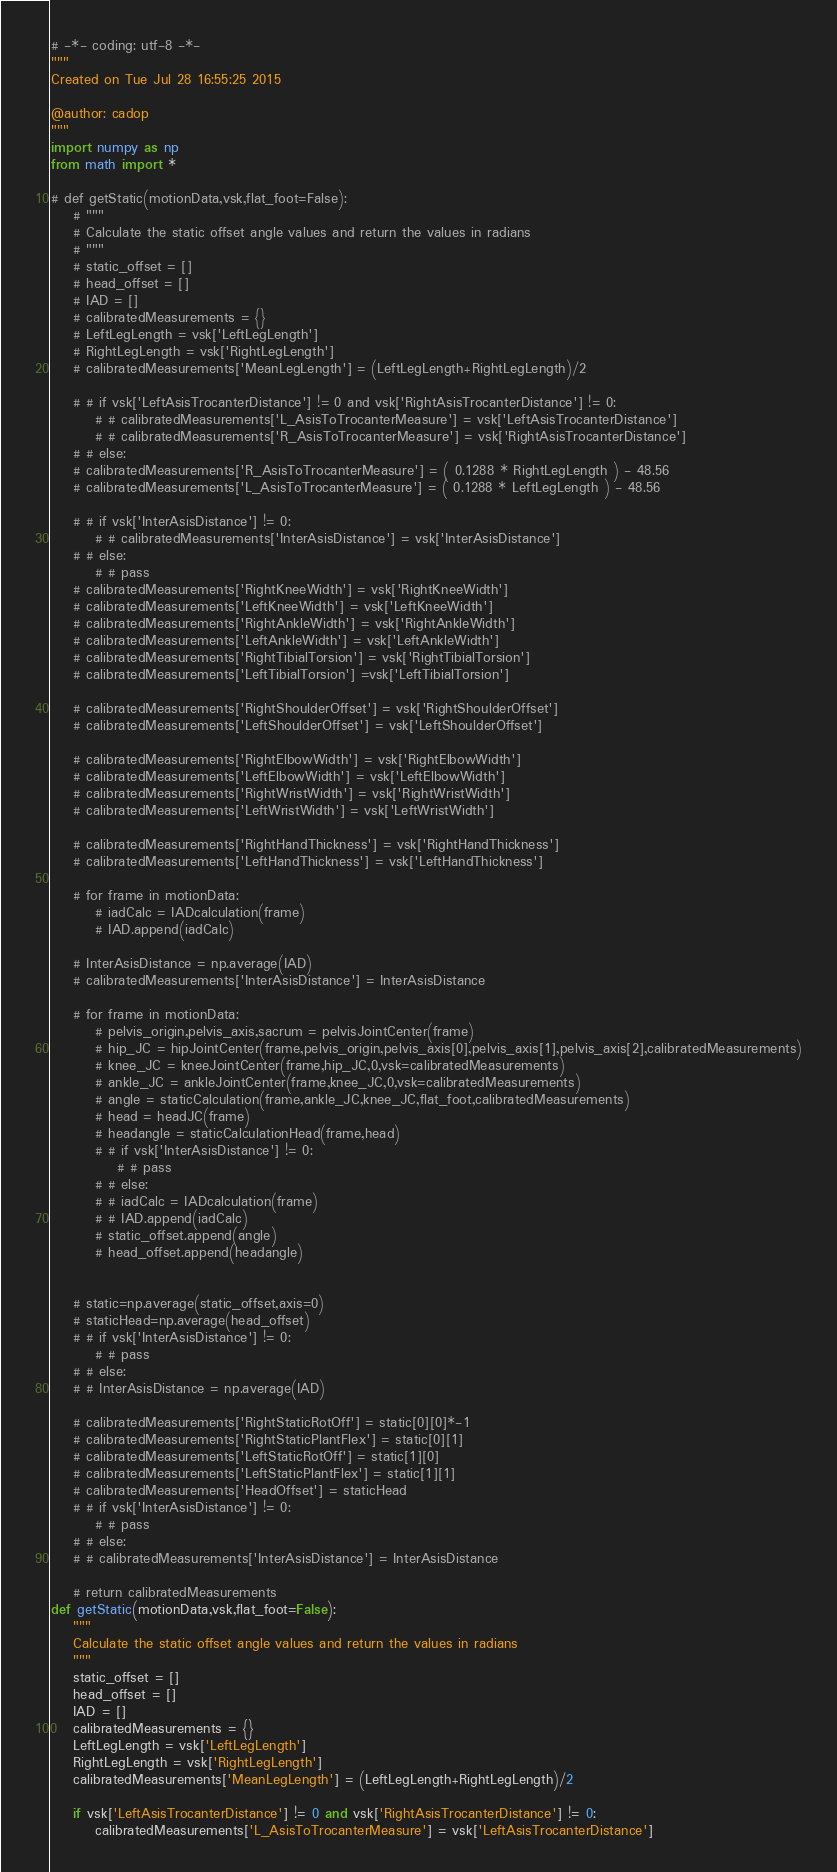Convert code to text. <code><loc_0><loc_0><loc_500><loc_500><_Python_># -*- coding: utf-8 -*-
"""
Created on Tue Jul 28 16:55:25 2015

@author: cadop
"""
import numpy as np
from math import *

# def getStatic(motionData,vsk,flat_foot=False):
	# """
	# Calculate the static offset angle values and return the values in radians
	# """
	# static_offset = []
	# head_offset = []
	# IAD = []
	# calibratedMeasurements = {}
	# LeftLegLength = vsk['LeftLegLength']
	# RightLegLength = vsk['RightLegLength']  
	# calibratedMeasurements['MeanLegLength'] = (LeftLegLength+RightLegLength)/2
	
	# # if vsk['LeftAsisTrocanterDistance'] != 0 and vsk['RightAsisTrocanterDistance'] != 0:
		# # calibratedMeasurements['L_AsisToTrocanterMeasure'] = vsk['LeftAsisTrocanterDistance']
		# # calibratedMeasurements['R_AsisToTrocanterMeasure'] = vsk['RightAsisTrocanterDistance']
	# # else:
	# calibratedMeasurements['R_AsisToTrocanterMeasure'] = ( 0.1288 * RightLegLength ) - 48.56
	# calibratedMeasurements['L_AsisToTrocanterMeasure'] = ( 0.1288 * LeftLegLength ) - 48.56
		
	# # if vsk['InterAsisDistance'] != 0:
		# # calibratedMeasurements['InterAsisDistance'] = vsk['InterAsisDistance']
	# # else:
		# # pass
	# calibratedMeasurements['RightKneeWidth'] = vsk['RightKneeWidth']
	# calibratedMeasurements['LeftKneeWidth'] = vsk['LeftKneeWidth']
	# calibratedMeasurements['RightAnkleWidth'] = vsk['RightAnkleWidth']
	# calibratedMeasurements['LeftAnkleWidth'] = vsk['LeftAnkleWidth']
	# calibratedMeasurements['RightTibialTorsion'] = vsk['RightTibialTorsion']
	# calibratedMeasurements['LeftTibialTorsion'] =vsk['LeftTibialTorsion']

	# calibratedMeasurements['RightShoulderOffset'] = vsk['RightShoulderOffset']
	# calibratedMeasurements['LeftShoulderOffset'] = vsk['LeftShoulderOffset']
    
	# calibratedMeasurements['RightElbowWidth'] = vsk['RightElbowWidth']
	# calibratedMeasurements['LeftElbowWidth'] = vsk['LeftElbowWidth']
	# calibratedMeasurements['RightWristWidth'] = vsk['RightWristWidth']
	# calibratedMeasurements['LeftWristWidth'] = vsk['LeftWristWidth']
    
	# calibratedMeasurements['RightHandThickness'] = vsk['RightHandThickness']
	# calibratedMeasurements['LeftHandThickness'] = vsk['LeftHandThickness']
	
	# for frame in motionData:
		# iadCalc = IADcalculation(frame)
		# IAD.append(iadCalc)
		
	# InterAsisDistance = np.average(IAD)
	# calibratedMeasurements['InterAsisDistance'] = InterAsisDistance
    
	# for frame in motionData:
		# pelvis_origin,pelvis_axis,sacrum = pelvisJointCenter(frame)
		# hip_JC = hipJointCenter(frame,pelvis_origin,pelvis_axis[0],pelvis_axis[1],pelvis_axis[2],calibratedMeasurements)
		# knee_JC = kneeJointCenter(frame,hip_JC,0,vsk=calibratedMeasurements)
		# ankle_JC = ankleJointCenter(frame,knee_JC,0,vsk=calibratedMeasurements)
		# angle = staticCalculation(frame,ankle_JC,knee_JC,flat_foot,calibratedMeasurements)
		# head = headJC(frame)
		# headangle = staticCalculationHead(frame,head)
		# # if vsk['InterAsisDistance'] != 0:
			# # pass
		# # else:
		# # iadCalc = IADcalculation(frame)
		# # IAD.append(iadCalc)
		# static_offset.append(angle)
		# head_offset.append(headangle)
		
	
	# static=np.average(static_offset,axis=0)
	# staticHead=np.average(head_offset)
	# # if vsk['InterAsisDistance'] != 0:
		# # pass
	# # else:
	# # InterAsisDistance = np.average(IAD)
	
	# calibratedMeasurements['RightStaticRotOff'] = static[0][0]*-1
	# calibratedMeasurements['RightStaticPlantFlex'] = static[0][1]
	# calibratedMeasurements['LeftStaticRotOff'] = static[1][0]
	# calibratedMeasurements['LeftStaticPlantFlex'] = static[1][1]
	# calibratedMeasurements['HeadOffset'] = staticHead
	# # if vsk['InterAsisDistance'] != 0:
		# # pass
	# # else:
	# # calibratedMeasurements['InterAsisDistance'] = InterAsisDistance

	# return calibratedMeasurements
def getStatic(motionData,vsk,flat_foot=False):
	"""
	Calculate the static offset angle values and return the values in radians
	"""
	static_offset = []
	head_offset = []
	IAD = []
	calibratedMeasurements = {}
	LeftLegLength = vsk['LeftLegLength']
	RightLegLength = vsk['RightLegLength']  
	calibratedMeasurements['MeanLegLength'] = (LeftLegLength+RightLegLength)/2
	
	if vsk['LeftAsisTrocanterDistance'] != 0 and vsk['RightAsisTrocanterDistance'] != 0:
		calibratedMeasurements['L_AsisToTrocanterMeasure'] = vsk['LeftAsisTrocanterDistance']</code> 